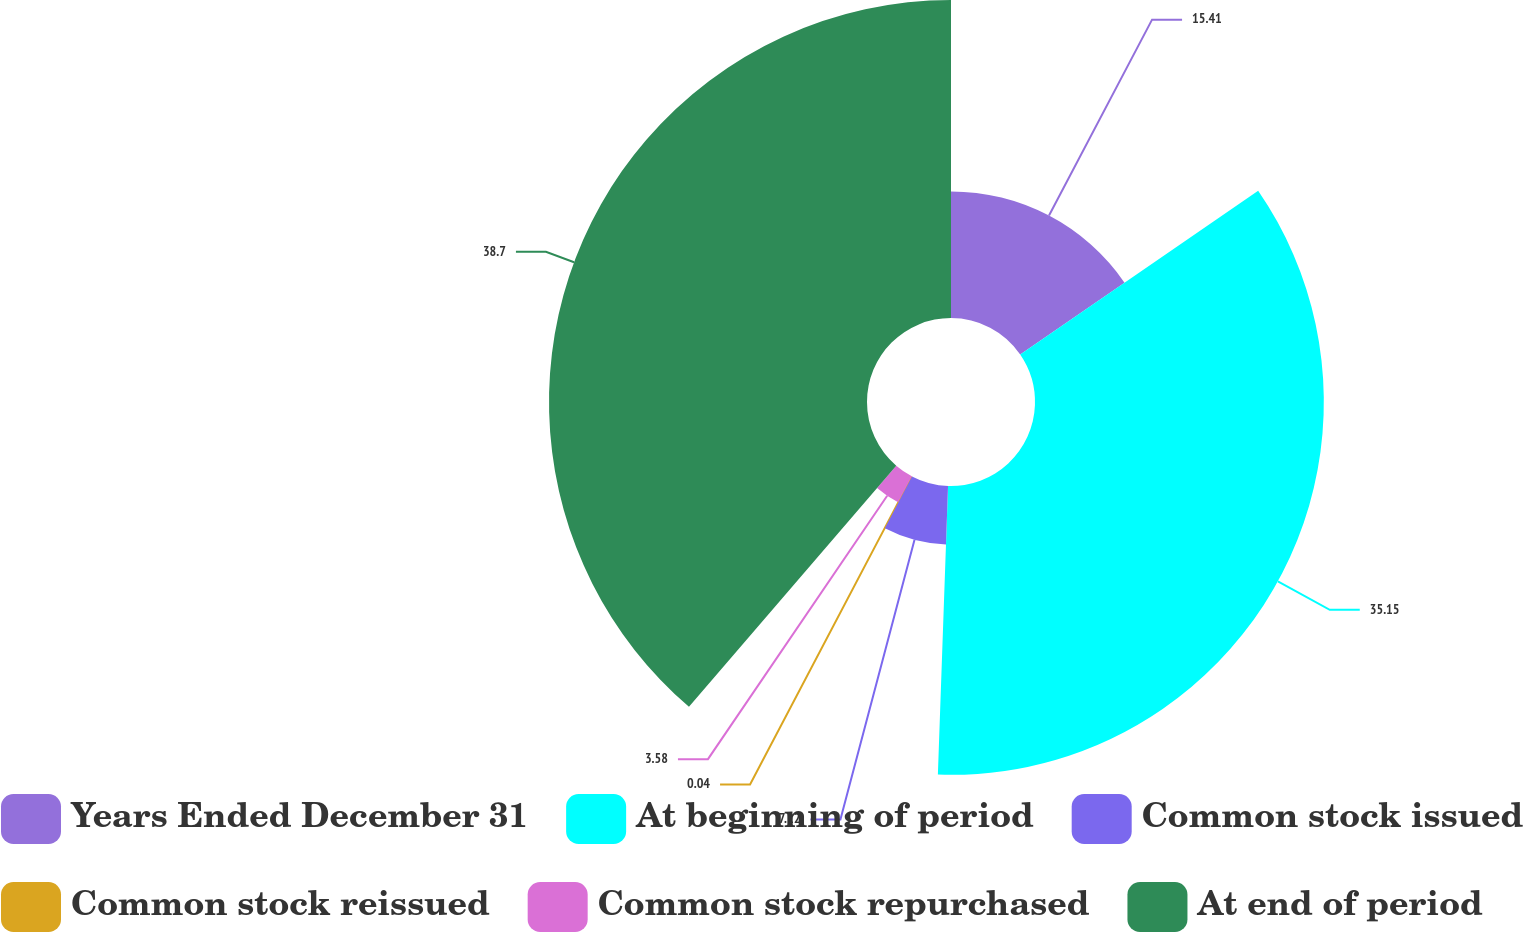Convert chart to OTSL. <chart><loc_0><loc_0><loc_500><loc_500><pie_chart><fcel>Years Ended December 31<fcel>At beginning of period<fcel>Common stock issued<fcel>Common stock reissued<fcel>Common stock repurchased<fcel>At end of period<nl><fcel>15.41%<fcel>35.15%<fcel>7.12%<fcel>0.04%<fcel>3.58%<fcel>38.7%<nl></chart> 